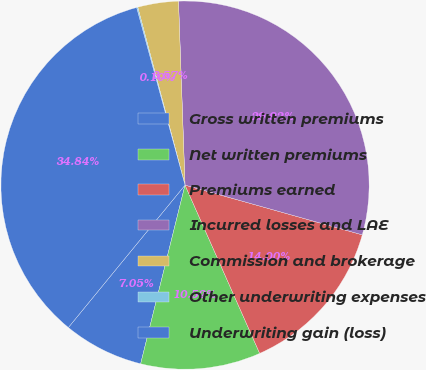Convert chart to OTSL. <chart><loc_0><loc_0><loc_500><loc_500><pie_chart><fcel>Gross written premiums<fcel>Net written premiums<fcel>Premiums earned<fcel>Incurred losses and LAE<fcel>Commission and brokerage<fcel>Other underwriting expenses<fcel>Underwriting gain (loss)<nl><fcel>7.05%<fcel>10.52%<fcel>14.0%<fcel>29.92%<fcel>3.57%<fcel>0.1%<fcel>34.84%<nl></chart> 